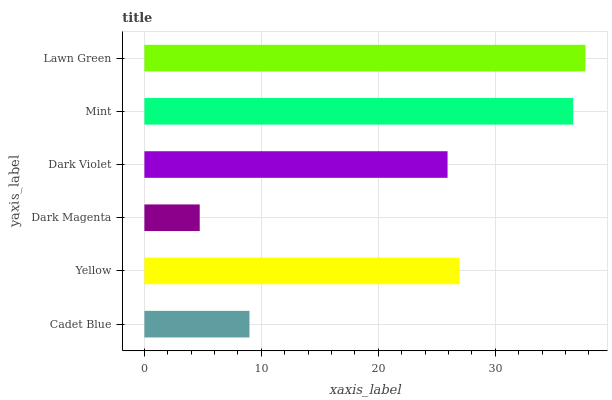Is Dark Magenta the minimum?
Answer yes or no. Yes. Is Lawn Green the maximum?
Answer yes or no. Yes. Is Yellow the minimum?
Answer yes or no. No. Is Yellow the maximum?
Answer yes or no. No. Is Yellow greater than Cadet Blue?
Answer yes or no. Yes. Is Cadet Blue less than Yellow?
Answer yes or no. Yes. Is Cadet Blue greater than Yellow?
Answer yes or no. No. Is Yellow less than Cadet Blue?
Answer yes or no. No. Is Yellow the high median?
Answer yes or no. Yes. Is Dark Violet the low median?
Answer yes or no. Yes. Is Dark Violet the high median?
Answer yes or no. No. Is Mint the low median?
Answer yes or no. No. 